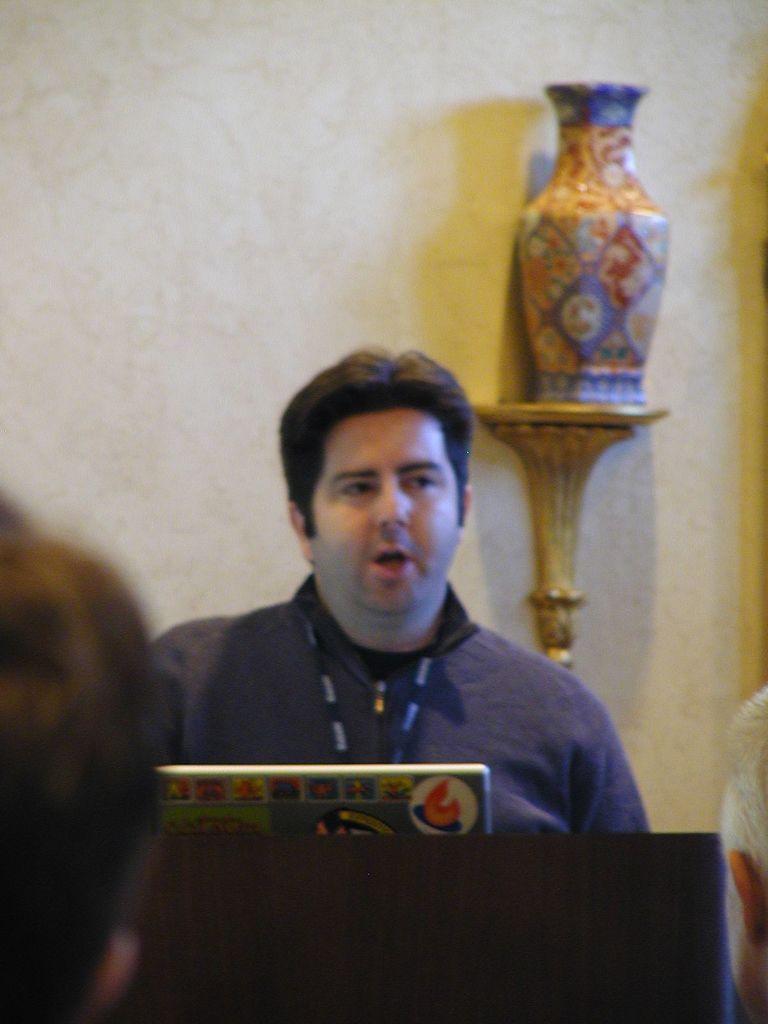Please provide a concise description of this image. In this image we can see a person and a laptop. At the bottom of the image there are persons and other objects. In the background of the image there is a wall, ceramic pot with some paintings and other objects. 